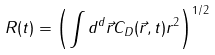Convert formula to latex. <formula><loc_0><loc_0><loc_500><loc_500>R ( t ) = { \left ( { \int { { d ^ { d } } \vec { r } { C _ { D } } ( \vec { r } , t ) { r ^ { 2 } } } } \right ) ^ { 1 / 2 } }</formula> 